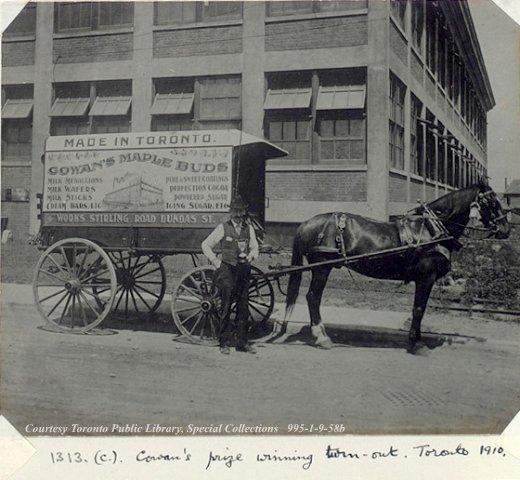How many horses?
Give a very brief answer. 1. How many doors are on the building?
Give a very brief answer. 0. How many horses are in front of the wagon?
Give a very brief answer. 1. How many wheels are visible?
Give a very brief answer. 4. How many trains are to the left of the doors?
Give a very brief answer. 0. 